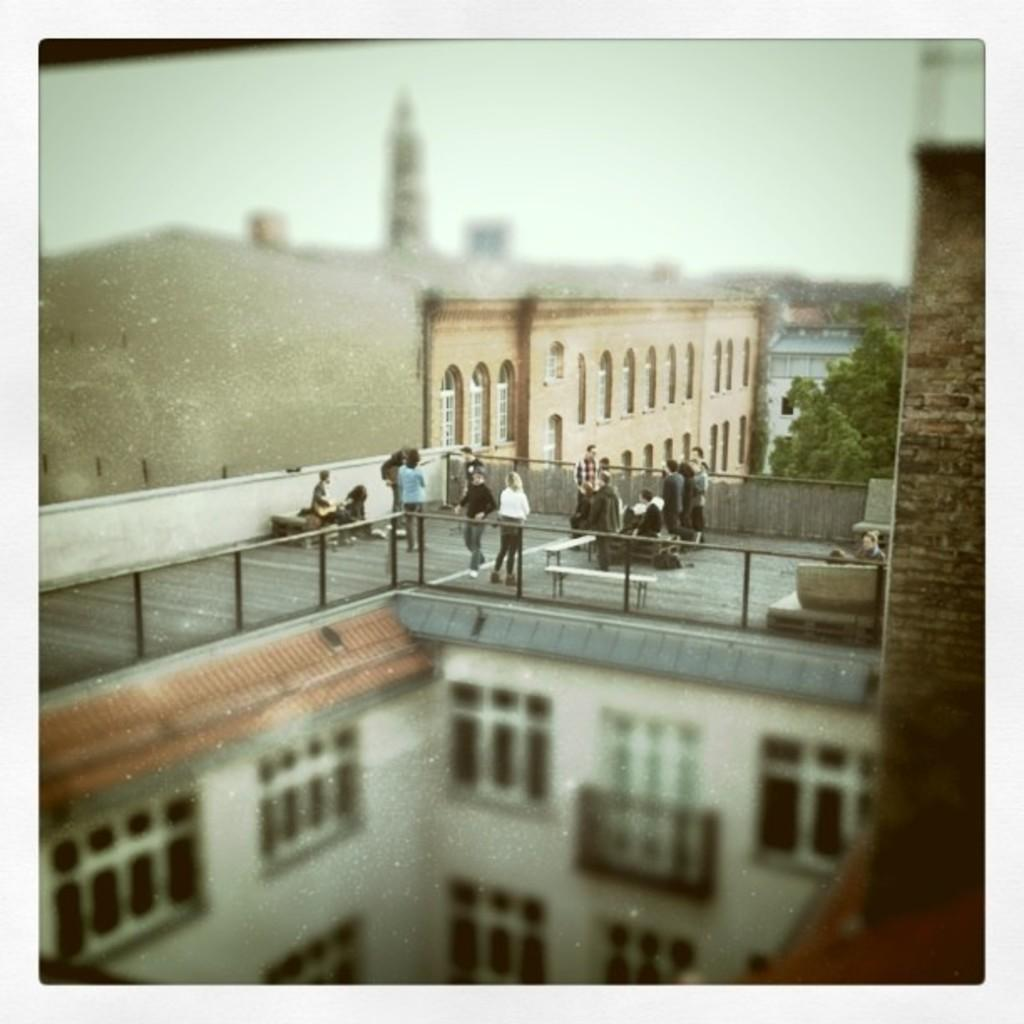What type of structures can be seen in the image? There are buildings and pillars in the image. What is visible in the sky in the image? The sky is visible in the image. What type of vegetation is present in the image? There are trees in the image. What are the people in the image doing? Some persons are standing on the floor, while others are sitting on benches in the image. How many sheep can be seen grazing on the grass in the image? There are no sheep present in the image. What type of maid is serving tea to the guests in the image? There is no maid or tea service depicted in the image. 